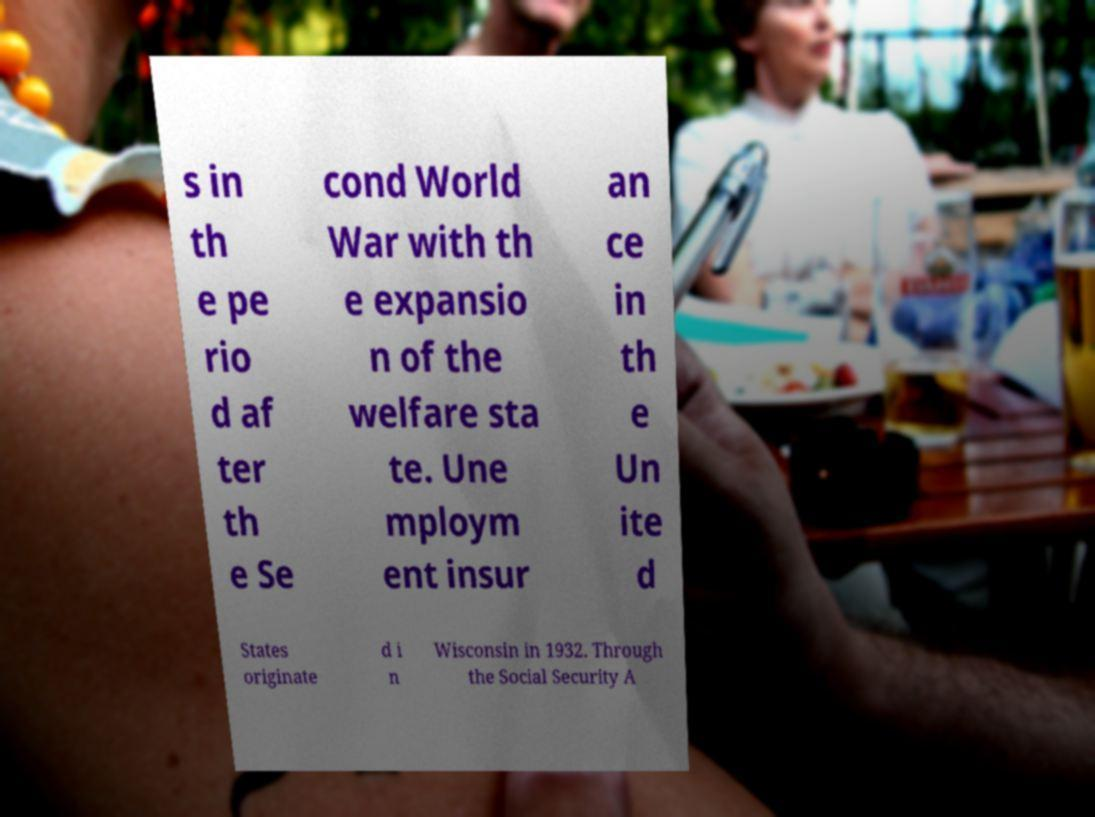There's text embedded in this image that I need extracted. Can you transcribe it verbatim? s in th e pe rio d af ter th e Se cond World War with th e expansio n of the welfare sta te. Une mploym ent insur an ce in th e Un ite d States originate d i n Wisconsin in 1932. Through the Social Security A 